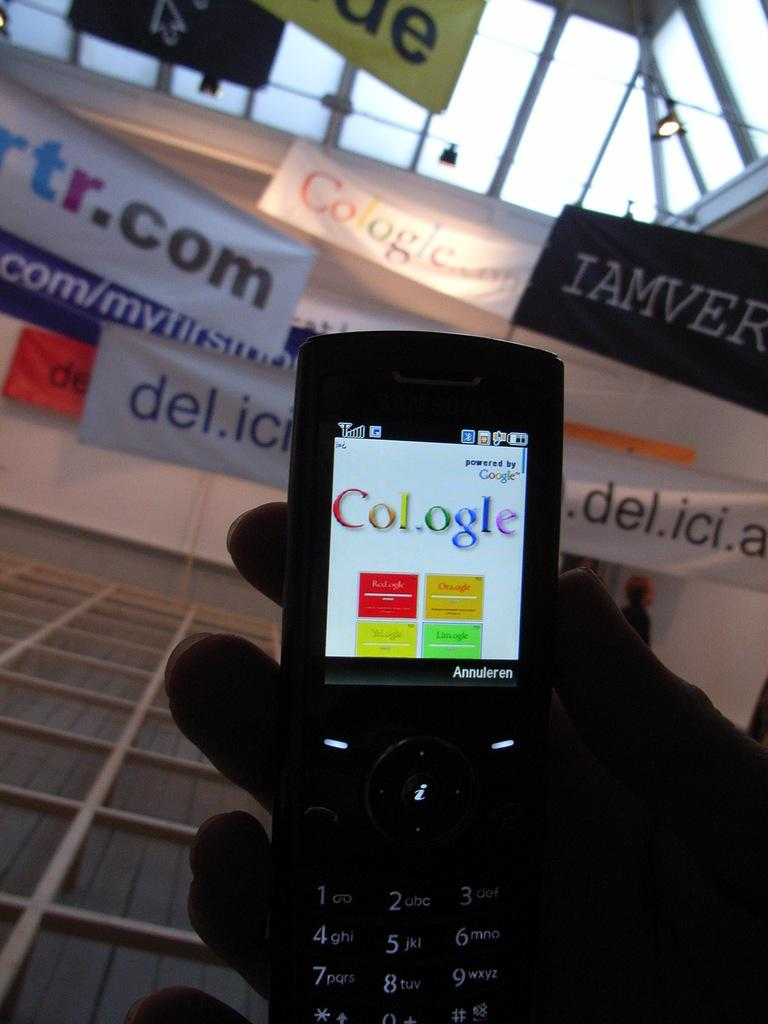<image>
Share a concise interpretation of the image provided. A flip phone has Col.ogle on its screen. 